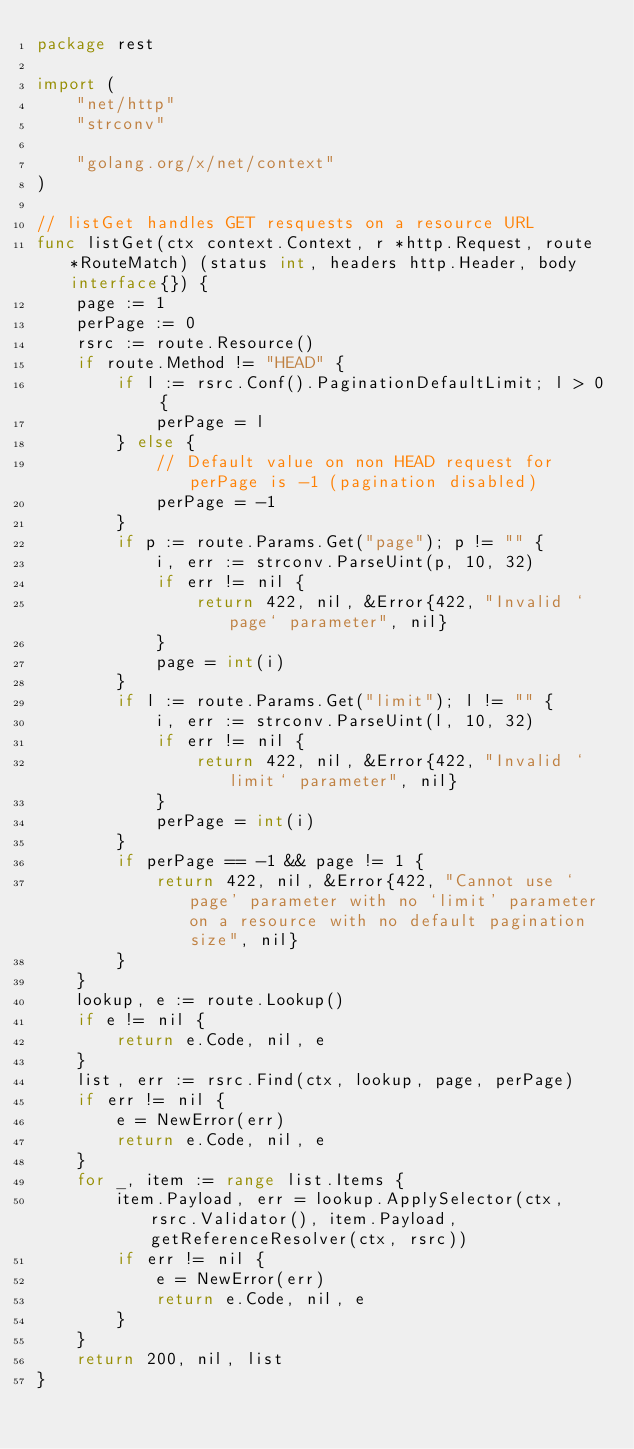Convert code to text. <code><loc_0><loc_0><loc_500><loc_500><_Go_>package rest

import (
	"net/http"
	"strconv"

	"golang.org/x/net/context"
)

// listGet handles GET resquests on a resource URL
func listGet(ctx context.Context, r *http.Request, route *RouteMatch) (status int, headers http.Header, body interface{}) {
	page := 1
	perPage := 0
	rsrc := route.Resource()
	if route.Method != "HEAD" {
		if l := rsrc.Conf().PaginationDefaultLimit; l > 0 {
			perPage = l
		} else {
			// Default value on non HEAD request for perPage is -1 (pagination disabled)
			perPage = -1
		}
		if p := route.Params.Get("page"); p != "" {
			i, err := strconv.ParseUint(p, 10, 32)
			if err != nil {
				return 422, nil, &Error{422, "Invalid `page` parameter", nil}
			}
			page = int(i)
		}
		if l := route.Params.Get("limit"); l != "" {
			i, err := strconv.ParseUint(l, 10, 32)
			if err != nil {
				return 422, nil, &Error{422, "Invalid `limit` parameter", nil}
			}
			perPage = int(i)
		}
		if perPage == -1 && page != 1 {
			return 422, nil, &Error{422, "Cannot use `page' parameter with no `limit' parameter on a resource with no default pagination size", nil}
		}
	}
	lookup, e := route.Lookup()
	if e != nil {
		return e.Code, nil, e
	}
	list, err := rsrc.Find(ctx, lookup, page, perPage)
	if err != nil {
		e = NewError(err)
		return e.Code, nil, e
	}
	for _, item := range list.Items {
		item.Payload, err = lookup.ApplySelector(ctx, rsrc.Validator(), item.Payload, getReferenceResolver(ctx, rsrc))
		if err != nil {
			e = NewError(err)
			return e.Code, nil, e
		}
	}
	return 200, nil, list
}
</code> 